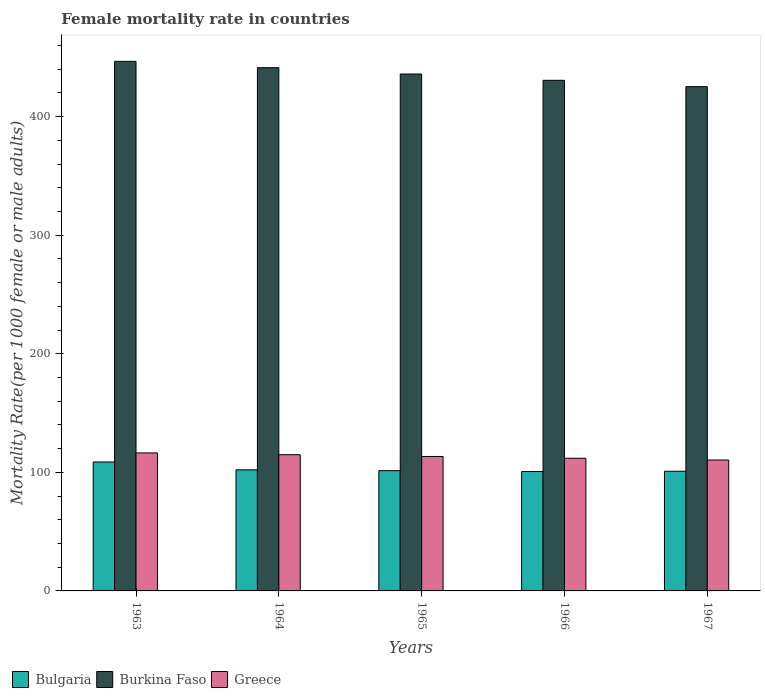How many different coloured bars are there?
Your answer should be very brief. 3. How many groups of bars are there?
Keep it short and to the point. 5. Are the number of bars per tick equal to the number of legend labels?
Give a very brief answer. Yes. How many bars are there on the 2nd tick from the right?
Provide a short and direct response. 3. What is the label of the 5th group of bars from the left?
Provide a short and direct response. 1967. In how many cases, is the number of bars for a given year not equal to the number of legend labels?
Provide a succinct answer. 0. What is the female mortality rate in Bulgaria in 1967?
Offer a very short reply. 100.95. Across all years, what is the maximum female mortality rate in Greece?
Give a very brief answer. 116.39. Across all years, what is the minimum female mortality rate in Burkina Faso?
Give a very brief answer. 425.33. In which year was the female mortality rate in Burkina Faso minimum?
Your answer should be compact. 1967. What is the total female mortality rate in Greece in the graph?
Provide a succinct answer. 567. What is the difference between the female mortality rate in Burkina Faso in 1964 and that in 1966?
Offer a very short reply. 10.67. What is the difference between the female mortality rate in Burkina Faso in 1965 and the female mortality rate in Bulgaria in 1967?
Your answer should be very brief. 335.05. What is the average female mortality rate in Bulgaria per year?
Offer a very short reply. 102.8. In the year 1965, what is the difference between the female mortality rate in Greece and female mortality rate in Burkina Faso?
Ensure brevity in your answer.  -322.6. In how many years, is the female mortality rate in Bulgaria greater than 80?
Provide a short and direct response. 5. What is the ratio of the female mortality rate in Greece in 1963 to that in 1964?
Your answer should be compact. 1.01. Is the female mortality rate in Bulgaria in 1964 less than that in 1967?
Keep it short and to the point. No. Is the difference between the female mortality rate in Greece in 1963 and 1964 greater than the difference between the female mortality rate in Burkina Faso in 1963 and 1964?
Provide a succinct answer. No. What is the difference between the highest and the second highest female mortality rate in Burkina Faso?
Your response must be concise. 5.34. What is the difference between the highest and the lowest female mortality rate in Burkina Faso?
Your answer should be very brief. 21.34. In how many years, is the female mortality rate in Bulgaria greater than the average female mortality rate in Bulgaria taken over all years?
Provide a succinct answer. 1. Is the sum of the female mortality rate in Bulgaria in 1964 and 1965 greater than the maximum female mortality rate in Burkina Faso across all years?
Offer a terse response. No. What does the 2nd bar from the left in 1964 represents?
Your response must be concise. Burkina Faso. What does the 2nd bar from the right in 1965 represents?
Give a very brief answer. Burkina Faso. Is it the case that in every year, the sum of the female mortality rate in Bulgaria and female mortality rate in Burkina Faso is greater than the female mortality rate in Greece?
Your answer should be compact. Yes. Are all the bars in the graph horizontal?
Provide a succinct answer. No. How many years are there in the graph?
Your answer should be very brief. 5. Does the graph contain grids?
Keep it short and to the point. No. Where does the legend appear in the graph?
Provide a succinct answer. Bottom left. How are the legend labels stacked?
Give a very brief answer. Horizontal. What is the title of the graph?
Keep it short and to the point. Female mortality rate in countries. What is the label or title of the Y-axis?
Your response must be concise. Mortality Rate(per 1000 female or male adults). What is the Mortality Rate(per 1000 female or male adults) in Bulgaria in 1963?
Keep it short and to the point. 108.75. What is the Mortality Rate(per 1000 female or male adults) in Burkina Faso in 1963?
Keep it short and to the point. 446.67. What is the Mortality Rate(per 1000 female or male adults) in Greece in 1963?
Provide a short and direct response. 116.39. What is the Mortality Rate(per 1000 female or male adults) in Bulgaria in 1964?
Make the answer very short. 102.14. What is the Mortality Rate(per 1000 female or male adults) of Burkina Faso in 1964?
Offer a terse response. 441.33. What is the Mortality Rate(per 1000 female or male adults) in Greece in 1964?
Your answer should be compact. 114.89. What is the Mortality Rate(per 1000 female or male adults) in Bulgaria in 1965?
Your answer should be very brief. 101.44. What is the Mortality Rate(per 1000 female or male adults) in Burkina Faso in 1965?
Your answer should be compact. 436. What is the Mortality Rate(per 1000 female or male adults) in Greece in 1965?
Make the answer very short. 113.4. What is the Mortality Rate(per 1000 female or male adults) in Bulgaria in 1966?
Your answer should be compact. 100.7. What is the Mortality Rate(per 1000 female or male adults) of Burkina Faso in 1966?
Keep it short and to the point. 430.67. What is the Mortality Rate(per 1000 female or male adults) in Greece in 1966?
Your answer should be compact. 111.91. What is the Mortality Rate(per 1000 female or male adults) in Bulgaria in 1967?
Give a very brief answer. 100.95. What is the Mortality Rate(per 1000 female or male adults) in Burkina Faso in 1967?
Keep it short and to the point. 425.33. What is the Mortality Rate(per 1000 female or male adults) of Greece in 1967?
Your answer should be very brief. 110.42. Across all years, what is the maximum Mortality Rate(per 1000 female or male adults) of Bulgaria?
Keep it short and to the point. 108.75. Across all years, what is the maximum Mortality Rate(per 1000 female or male adults) in Burkina Faso?
Offer a terse response. 446.67. Across all years, what is the maximum Mortality Rate(per 1000 female or male adults) in Greece?
Provide a short and direct response. 116.39. Across all years, what is the minimum Mortality Rate(per 1000 female or male adults) in Bulgaria?
Your response must be concise. 100.7. Across all years, what is the minimum Mortality Rate(per 1000 female or male adults) in Burkina Faso?
Offer a very short reply. 425.33. Across all years, what is the minimum Mortality Rate(per 1000 female or male adults) of Greece?
Provide a short and direct response. 110.42. What is the total Mortality Rate(per 1000 female or male adults) of Bulgaria in the graph?
Offer a terse response. 513.98. What is the total Mortality Rate(per 1000 female or male adults) of Burkina Faso in the graph?
Your answer should be compact. 2180. What is the total Mortality Rate(per 1000 female or male adults) of Greece in the graph?
Provide a short and direct response. 567. What is the difference between the Mortality Rate(per 1000 female or male adults) of Bulgaria in 1963 and that in 1964?
Provide a short and direct response. 6.62. What is the difference between the Mortality Rate(per 1000 female or male adults) of Burkina Faso in 1963 and that in 1964?
Make the answer very short. 5.33. What is the difference between the Mortality Rate(per 1000 female or male adults) in Greece in 1963 and that in 1964?
Ensure brevity in your answer.  1.49. What is the difference between the Mortality Rate(per 1000 female or male adults) of Bulgaria in 1963 and that in 1965?
Offer a terse response. 7.31. What is the difference between the Mortality Rate(per 1000 female or male adults) of Burkina Faso in 1963 and that in 1965?
Offer a very short reply. 10.67. What is the difference between the Mortality Rate(per 1000 female or male adults) in Greece in 1963 and that in 1965?
Provide a short and direct response. 2.99. What is the difference between the Mortality Rate(per 1000 female or male adults) of Bulgaria in 1963 and that in 1966?
Offer a very short reply. 8.05. What is the difference between the Mortality Rate(per 1000 female or male adults) in Burkina Faso in 1963 and that in 1966?
Keep it short and to the point. 16. What is the difference between the Mortality Rate(per 1000 female or male adults) of Greece in 1963 and that in 1966?
Keep it short and to the point. 4.48. What is the difference between the Mortality Rate(per 1000 female or male adults) of Bulgaria in 1963 and that in 1967?
Ensure brevity in your answer.  7.8. What is the difference between the Mortality Rate(per 1000 female or male adults) of Burkina Faso in 1963 and that in 1967?
Keep it short and to the point. 21.34. What is the difference between the Mortality Rate(per 1000 female or male adults) of Greece in 1963 and that in 1967?
Make the answer very short. 5.97. What is the difference between the Mortality Rate(per 1000 female or male adults) of Bulgaria in 1964 and that in 1965?
Offer a very short reply. 0.7. What is the difference between the Mortality Rate(per 1000 female or male adults) of Burkina Faso in 1964 and that in 1965?
Give a very brief answer. 5.33. What is the difference between the Mortality Rate(per 1000 female or male adults) in Greece in 1964 and that in 1965?
Offer a terse response. 1.49. What is the difference between the Mortality Rate(per 1000 female or male adults) in Bulgaria in 1964 and that in 1966?
Provide a succinct answer. 1.44. What is the difference between the Mortality Rate(per 1000 female or male adults) of Burkina Faso in 1964 and that in 1966?
Your answer should be compact. 10.67. What is the difference between the Mortality Rate(per 1000 female or male adults) of Greece in 1964 and that in 1966?
Keep it short and to the point. 2.99. What is the difference between the Mortality Rate(per 1000 female or male adults) in Bulgaria in 1964 and that in 1967?
Your answer should be compact. 1.19. What is the difference between the Mortality Rate(per 1000 female or male adults) in Burkina Faso in 1964 and that in 1967?
Your response must be concise. 16. What is the difference between the Mortality Rate(per 1000 female or male adults) of Greece in 1964 and that in 1967?
Your answer should be compact. 4.48. What is the difference between the Mortality Rate(per 1000 female or male adults) in Bulgaria in 1965 and that in 1966?
Your answer should be very brief. 0.74. What is the difference between the Mortality Rate(per 1000 female or male adults) of Burkina Faso in 1965 and that in 1966?
Offer a terse response. 5.33. What is the difference between the Mortality Rate(per 1000 female or male adults) of Greece in 1965 and that in 1966?
Offer a terse response. 1.49. What is the difference between the Mortality Rate(per 1000 female or male adults) of Bulgaria in 1965 and that in 1967?
Make the answer very short. 0.49. What is the difference between the Mortality Rate(per 1000 female or male adults) of Burkina Faso in 1965 and that in 1967?
Provide a succinct answer. 10.67. What is the difference between the Mortality Rate(per 1000 female or male adults) of Greece in 1965 and that in 1967?
Provide a succinct answer. 2.99. What is the difference between the Mortality Rate(per 1000 female or male adults) in Bulgaria in 1966 and that in 1967?
Provide a short and direct response. -0.25. What is the difference between the Mortality Rate(per 1000 female or male adults) in Burkina Faso in 1966 and that in 1967?
Offer a terse response. 5.33. What is the difference between the Mortality Rate(per 1000 female or male adults) in Greece in 1966 and that in 1967?
Your response must be concise. 1.49. What is the difference between the Mortality Rate(per 1000 female or male adults) in Bulgaria in 1963 and the Mortality Rate(per 1000 female or male adults) in Burkina Faso in 1964?
Your answer should be very brief. -332.58. What is the difference between the Mortality Rate(per 1000 female or male adults) in Bulgaria in 1963 and the Mortality Rate(per 1000 female or male adults) in Greece in 1964?
Ensure brevity in your answer.  -6.14. What is the difference between the Mortality Rate(per 1000 female or male adults) in Burkina Faso in 1963 and the Mortality Rate(per 1000 female or male adults) in Greece in 1964?
Offer a very short reply. 331.78. What is the difference between the Mortality Rate(per 1000 female or male adults) of Bulgaria in 1963 and the Mortality Rate(per 1000 female or male adults) of Burkina Faso in 1965?
Your answer should be compact. -327.25. What is the difference between the Mortality Rate(per 1000 female or male adults) in Bulgaria in 1963 and the Mortality Rate(per 1000 female or male adults) in Greece in 1965?
Your answer should be very brief. -4.65. What is the difference between the Mortality Rate(per 1000 female or male adults) of Burkina Faso in 1963 and the Mortality Rate(per 1000 female or male adults) of Greece in 1965?
Provide a succinct answer. 333.27. What is the difference between the Mortality Rate(per 1000 female or male adults) of Bulgaria in 1963 and the Mortality Rate(per 1000 female or male adults) of Burkina Faso in 1966?
Your answer should be very brief. -321.91. What is the difference between the Mortality Rate(per 1000 female or male adults) in Bulgaria in 1963 and the Mortality Rate(per 1000 female or male adults) in Greece in 1966?
Keep it short and to the point. -3.16. What is the difference between the Mortality Rate(per 1000 female or male adults) of Burkina Faso in 1963 and the Mortality Rate(per 1000 female or male adults) of Greece in 1966?
Your answer should be compact. 334.76. What is the difference between the Mortality Rate(per 1000 female or male adults) in Bulgaria in 1963 and the Mortality Rate(per 1000 female or male adults) in Burkina Faso in 1967?
Give a very brief answer. -316.58. What is the difference between the Mortality Rate(per 1000 female or male adults) of Bulgaria in 1963 and the Mortality Rate(per 1000 female or male adults) of Greece in 1967?
Provide a short and direct response. -1.66. What is the difference between the Mortality Rate(per 1000 female or male adults) of Burkina Faso in 1963 and the Mortality Rate(per 1000 female or male adults) of Greece in 1967?
Make the answer very short. 336.25. What is the difference between the Mortality Rate(per 1000 female or male adults) in Bulgaria in 1964 and the Mortality Rate(per 1000 female or male adults) in Burkina Faso in 1965?
Make the answer very short. -333.86. What is the difference between the Mortality Rate(per 1000 female or male adults) of Bulgaria in 1964 and the Mortality Rate(per 1000 female or male adults) of Greece in 1965?
Keep it short and to the point. -11.26. What is the difference between the Mortality Rate(per 1000 female or male adults) of Burkina Faso in 1964 and the Mortality Rate(per 1000 female or male adults) of Greece in 1965?
Provide a succinct answer. 327.93. What is the difference between the Mortality Rate(per 1000 female or male adults) of Bulgaria in 1964 and the Mortality Rate(per 1000 female or male adults) of Burkina Faso in 1966?
Provide a short and direct response. -328.53. What is the difference between the Mortality Rate(per 1000 female or male adults) in Bulgaria in 1964 and the Mortality Rate(per 1000 female or male adults) in Greece in 1966?
Keep it short and to the point. -9.77. What is the difference between the Mortality Rate(per 1000 female or male adults) of Burkina Faso in 1964 and the Mortality Rate(per 1000 female or male adults) of Greece in 1966?
Your answer should be compact. 329.43. What is the difference between the Mortality Rate(per 1000 female or male adults) in Bulgaria in 1964 and the Mortality Rate(per 1000 female or male adults) in Burkina Faso in 1967?
Provide a short and direct response. -323.19. What is the difference between the Mortality Rate(per 1000 female or male adults) of Bulgaria in 1964 and the Mortality Rate(per 1000 female or male adults) of Greece in 1967?
Offer a very short reply. -8.28. What is the difference between the Mortality Rate(per 1000 female or male adults) of Burkina Faso in 1964 and the Mortality Rate(per 1000 female or male adults) of Greece in 1967?
Provide a succinct answer. 330.92. What is the difference between the Mortality Rate(per 1000 female or male adults) in Bulgaria in 1965 and the Mortality Rate(per 1000 female or male adults) in Burkina Faso in 1966?
Ensure brevity in your answer.  -329.23. What is the difference between the Mortality Rate(per 1000 female or male adults) of Bulgaria in 1965 and the Mortality Rate(per 1000 female or male adults) of Greece in 1966?
Offer a terse response. -10.47. What is the difference between the Mortality Rate(per 1000 female or male adults) in Burkina Faso in 1965 and the Mortality Rate(per 1000 female or male adults) in Greece in 1966?
Offer a terse response. 324.09. What is the difference between the Mortality Rate(per 1000 female or male adults) of Bulgaria in 1965 and the Mortality Rate(per 1000 female or male adults) of Burkina Faso in 1967?
Your answer should be compact. -323.89. What is the difference between the Mortality Rate(per 1000 female or male adults) of Bulgaria in 1965 and the Mortality Rate(per 1000 female or male adults) of Greece in 1967?
Offer a terse response. -8.97. What is the difference between the Mortality Rate(per 1000 female or male adults) in Burkina Faso in 1965 and the Mortality Rate(per 1000 female or male adults) in Greece in 1967?
Offer a terse response. 325.58. What is the difference between the Mortality Rate(per 1000 female or male adults) of Bulgaria in 1966 and the Mortality Rate(per 1000 female or male adults) of Burkina Faso in 1967?
Ensure brevity in your answer.  -324.63. What is the difference between the Mortality Rate(per 1000 female or male adults) in Bulgaria in 1966 and the Mortality Rate(per 1000 female or male adults) in Greece in 1967?
Give a very brief answer. -9.72. What is the difference between the Mortality Rate(per 1000 female or male adults) of Burkina Faso in 1966 and the Mortality Rate(per 1000 female or male adults) of Greece in 1967?
Make the answer very short. 320.25. What is the average Mortality Rate(per 1000 female or male adults) of Bulgaria per year?
Your answer should be compact. 102.8. What is the average Mortality Rate(per 1000 female or male adults) of Burkina Faso per year?
Provide a succinct answer. 436. What is the average Mortality Rate(per 1000 female or male adults) of Greece per year?
Your response must be concise. 113.4. In the year 1963, what is the difference between the Mortality Rate(per 1000 female or male adults) in Bulgaria and Mortality Rate(per 1000 female or male adults) in Burkina Faso?
Your answer should be compact. -337.92. In the year 1963, what is the difference between the Mortality Rate(per 1000 female or male adults) of Bulgaria and Mortality Rate(per 1000 female or male adults) of Greece?
Give a very brief answer. -7.63. In the year 1963, what is the difference between the Mortality Rate(per 1000 female or male adults) of Burkina Faso and Mortality Rate(per 1000 female or male adults) of Greece?
Ensure brevity in your answer.  330.28. In the year 1964, what is the difference between the Mortality Rate(per 1000 female or male adults) of Bulgaria and Mortality Rate(per 1000 female or male adults) of Burkina Faso?
Provide a succinct answer. -339.2. In the year 1964, what is the difference between the Mortality Rate(per 1000 female or male adults) of Bulgaria and Mortality Rate(per 1000 female or male adults) of Greece?
Your answer should be compact. -12.76. In the year 1964, what is the difference between the Mortality Rate(per 1000 female or male adults) of Burkina Faso and Mortality Rate(per 1000 female or male adults) of Greece?
Give a very brief answer. 326.44. In the year 1965, what is the difference between the Mortality Rate(per 1000 female or male adults) in Bulgaria and Mortality Rate(per 1000 female or male adults) in Burkina Faso?
Offer a terse response. -334.56. In the year 1965, what is the difference between the Mortality Rate(per 1000 female or male adults) in Bulgaria and Mortality Rate(per 1000 female or male adults) in Greece?
Give a very brief answer. -11.96. In the year 1965, what is the difference between the Mortality Rate(per 1000 female or male adults) in Burkina Faso and Mortality Rate(per 1000 female or male adults) in Greece?
Offer a very short reply. 322.6. In the year 1966, what is the difference between the Mortality Rate(per 1000 female or male adults) of Bulgaria and Mortality Rate(per 1000 female or male adults) of Burkina Faso?
Your answer should be very brief. -329.97. In the year 1966, what is the difference between the Mortality Rate(per 1000 female or male adults) in Bulgaria and Mortality Rate(per 1000 female or male adults) in Greece?
Provide a short and direct response. -11.21. In the year 1966, what is the difference between the Mortality Rate(per 1000 female or male adults) in Burkina Faso and Mortality Rate(per 1000 female or male adults) in Greece?
Provide a succinct answer. 318.76. In the year 1967, what is the difference between the Mortality Rate(per 1000 female or male adults) in Bulgaria and Mortality Rate(per 1000 female or male adults) in Burkina Faso?
Provide a short and direct response. -324.38. In the year 1967, what is the difference between the Mortality Rate(per 1000 female or male adults) of Bulgaria and Mortality Rate(per 1000 female or male adults) of Greece?
Your answer should be very brief. -9.47. In the year 1967, what is the difference between the Mortality Rate(per 1000 female or male adults) of Burkina Faso and Mortality Rate(per 1000 female or male adults) of Greece?
Give a very brief answer. 314.92. What is the ratio of the Mortality Rate(per 1000 female or male adults) of Bulgaria in 1963 to that in 1964?
Your response must be concise. 1.06. What is the ratio of the Mortality Rate(per 1000 female or male adults) in Burkina Faso in 1963 to that in 1964?
Provide a succinct answer. 1.01. What is the ratio of the Mortality Rate(per 1000 female or male adults) of Bulgaria in 1963 to that in 1965?
Provide a succinct answer. 1.07. What is the ratio of the Mortality Rate(per 1000 female or male adults) of Burkina Faso in 1963 to that in 1965?
Give a very brief answer. 1.02. What is the ratio of the Mortality Rate(per 1000 female or male adults) in Greece in 1963 to that in 1965?
Your response must be concise. 1.03. What is the ratio of the Mortality Rate(per 1000 female or male adults) in Burkina Faso in 1963 to that in 1966?
Offer a very short reply. 1.04. What is the ratio of the Mortality Rate(per 1000 female or male adults) in Bulgaria in 1963 to that in 1967?
Make the answer very short. 1.08. What is the ratio of the Mortality Rate(per 1000 female or male adults) in Burkina Faso in 1963 to that in 1967?
Give a very brief answer. 1.05. What is the ratio of the Mortality Rate(per 1000 female or male adults) in Greece in 1963 to that in 1967?
Keep it short and to the point. 1.05. What is the ratio of the Mortality Rate(per 1000 female or male adults) in Burkina Faso in 1964 to that in 1965?
Offer a terse response. 1.01. What is the ratio of the Mortality Rate(per 1000 female or male adults) of Greece in 1964 to that in 1965?
Provide a short and direct response. 1.01. What is the ratio of the Mortality Rate(per 1000 female or male adults) in Bulgaria in 1964 to that in 1966?
Offer a terse response. 1.01. What is the ratio of the Mortality Rate(per 1000 female or male adults) of Burkina Faso in 1964 to that in 1966?
Provide a succinct answer. 1.02. What is the ratio of the Mortality Rate(per 1000 female or male adults) in Greece in 1964 to that in 1966?
Your answer should be compact. 1.03. What is the ratio of the Mortality Rate(per 1000 female or male adults) in Bulgaria in 1964 to that in 1967?
Give a very brief answer. 1.01. What is the ratio of the Mortality Rate(per 1000 female or male adults) in Burkina Faso in 1964 to that in 1967?
Offer a terse response. 1.04. What is the ratio of the Mortality Rate(per 1000 female or male adults) in Greece in 1964 to that in 1967?
Your answer should be compact. 1.04. What is the ratio of the Mortality Rate(per 1000 female or male adults) of Bulgaria in 1965 to that in 1966?
Your answer should be compact. 1.01. What is the ratio of the Mortality Rate(per 1000 female or male adults) in Burkina Faso in 1965 to that in 1966?
Ensure brevity in your answer.  1.01. What is the ratio of the Mortality Rate(per 1000 female or male adults) in Greece in 1965 to that in 1966?
Keep it short and to the point. 1.01. What is the ratio of the Mortality Rate(per 1000 female or male adults) in Bulgaria in 1965 to that in 1967?
Provide a succinct answer. 1. What is the ratio of the Mortality Rate(per 1000 female or male adults) of Burkina Faso in 1965 to that in 1967?
Provide a succinct answer. 1.03. What is the ratio of the Mortality Rate(per 1000 female or male adults) in Greece in 1965 to that in 1967?
Give a very brief answer. 1.03. What is the ratio of the Mortality Rate(per 1000 female or male adults) of Bulgaria in 1966 to that in 1967?
Your response must be concise. 1. What is the ratio of the Mortality Rate(per 1000 female or male adults) in Burkina Faso in 1966 to that in 1967?
Ensure brevity in your answer.  1.01. What is the ratio of the Mortality Rate(per 1000 female or male adults) of Greece in 1966 to that in 1967?
Provide a succinct answer. 1.01. What is the difference between the highest and the second highest Mortality Rate(per 1000 female or male adults) of Bulgaria?
Make the answer very short. 6.62. What is the difference between the highest and the second highest Mortality Rate(per 1000 female or male adults) of Burkina Faso?
Ensure brevity in your answer.  5.33. What is the difference between the highest and the second highest Mortality Rate(per 1000 female or male adults) in Greece?
Keep it short and to the point. 1.49. What is the difference between the highest and the lowest Mortality Rate(per 1000 female or male adults) in Bulgaria?
Keep it short and to the point. 8.05. What is the difference between the highest and the lowest Mortality Rate(per 1000 female or male adults) in Burkina Faso?
Your answer should be compact. 21.34. What is the difference between the highest and the lowest Mortality Rate(per 1000 female or male adults) in Greece?
Your answer should be compact. 5.97. 